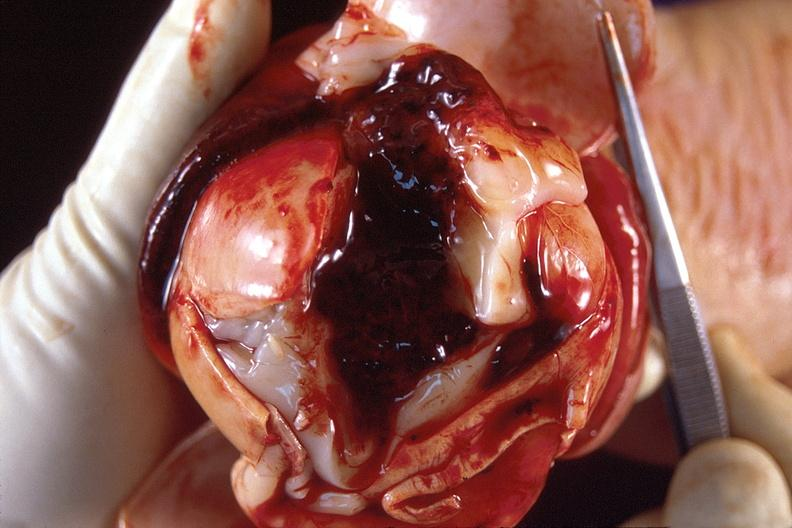does this image show brain, intraventricular hemorrhage?
Answer the question using a single word or phrase. Yes 